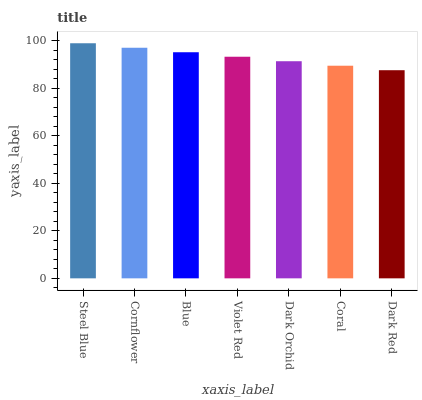Is Dark Red the minimum?
Answer yes or no. Yes. Is Steel Blue the maximum?
Answer yes or no. Yes. Is Cornflower the minimum?
Answer yes or no. No. Is Cornflower the maximum?
Answer yes or no. No. Is Steel Blue greater than Cornflower?
Answer yes or no. Yes. Is Cornflower less than Steel Blue?
Answer yes or no. Yes. Is Cornflower greater than Steel Blue?
Answer yes or no. No. Is Steel Blue less than Cornflower?
Answer yes or no. No. Is Violet Red the high median?
Answer yes or no. Yes. Is Violet Red the low median?
Answer yes or no. Yes. Is Steel Blue the high median?
Answer yes or no. No. Is Coral the low median?
Answer yes or no. No. 